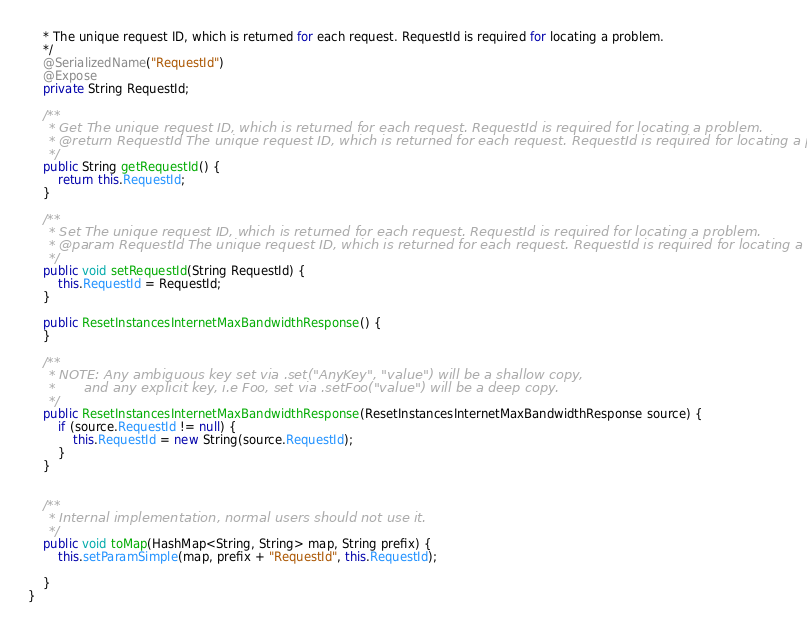<code> <loc_0><loc_0><loc_500><loc_500><_Java_>    * The unique request ID, which is returned for each request. RequestId is required for locating a problem.
    */
    @SerializedName("RequestId")
    @Expose
    private String RequestId;

    /**
     * Get The unique request ID, which is returned for each request. RequestId is required for locating a problem. 
     * @return RequestId The unique request ID, which is returned for each request. RequestId is required for locating a problem.
     */
    public String getRequestId() {
        return this.RequestId;
    }

    /**
     * Set The unique request ID, which is returned for each request. RequestId is required for locating a problem.
     * @param RequestId The unique request ID, which is returned for each request. RequestId is required for locating a problem.
     */
    public void setRequestId(String RequestId) {
        this.RequestId = RequestId;
    }

    public ResetInstancesInternetMaxBandwidthResponse() {
    }

    /**
     * NOTE: Any ambiguous key set via .set("AnyKey", "value") will be a shallow copy,
     *       and any explicit key, i.e Foo, set via .setFoo("value") will be a deep copy.
     */
    public ResetInstancesInternetMaxBandwidthResponse(ResetInstancesInternetMaxBandwidthResponse source) {
        if (source.RequestId != null) {
            this.RequestId = new String(source.RequestId);
        }
    }


    /**
     * Internal implementation, normal users should not use it.
     */
    public void toMap(HashMap<String, String> map, String prefix) {
        this.setParamSimple(map, prefix + "RequestId", this.RequestId);

    }
}

</code> 